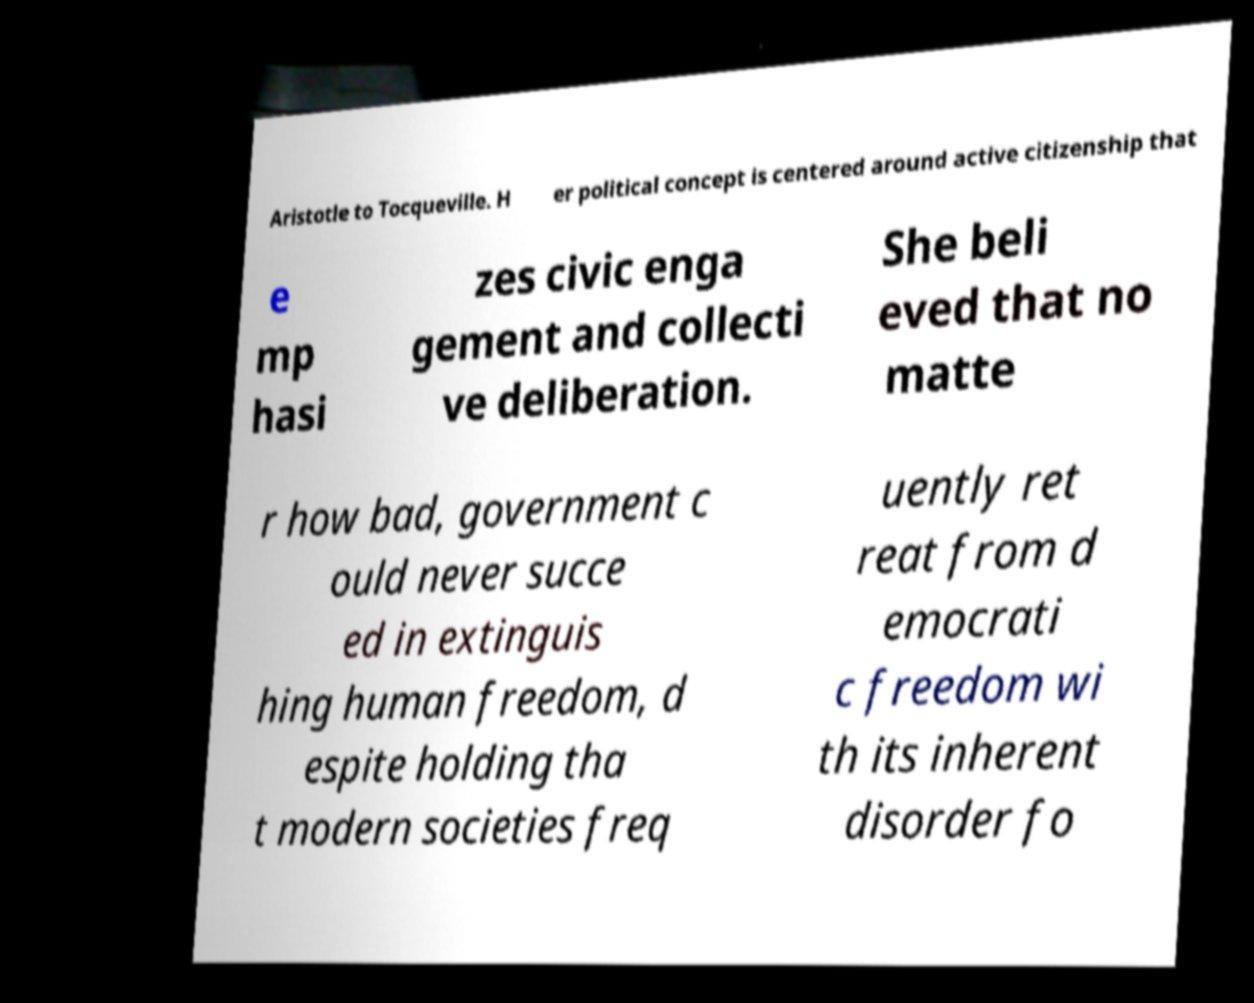Could you extract and type out the text from this image? Aristotle to Tocqueville. H er political concept is centered around active citizenship that e mp hasi zes civic enga gement and collecti ve deliberation. She beli eved that no matte r how bad, government c ould never succe ed in extinguis hing human freedom, d espite holding tha t modern societies freq uently ret reat from d emocrati c freedom wi th its inherent disorder fo 